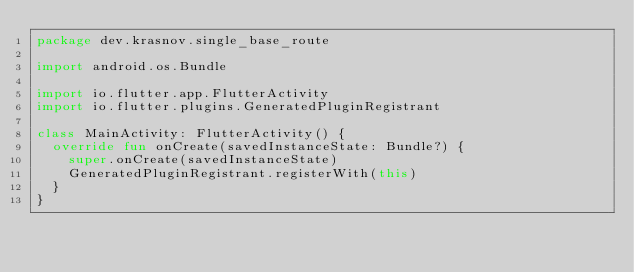<code> <loc_0><loc_0><loc_500><loc_500><_Kotlin_>package dev.krasnov.single_base_route

import android.os.Bundle

import io.flutter.app.FlutterActivity
import io.flutter.plugins.GeneratedPluginRegistrant

class MainActivity: FlutterActivity() {
  override fun onCreate(savedInstanceState: Bundle?) {
    super.onCreate(savedInstanceState)
    GeneratedPluginRegistrant.registerWith(this)
  }
}
</code> 